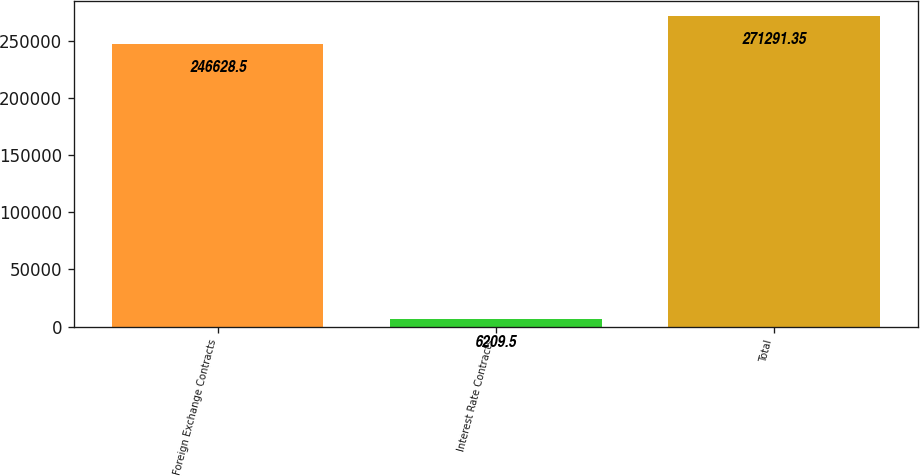<chart> <loc_0><loc_0><loc_500><loc_500><bar_chart><fcel>Foreign Exchange Contracts<fcel>Interest Rate Contracts<fcel>Total<nl><fcel>246628<fcel>6209.5<fcel>271291<nl></chart> 